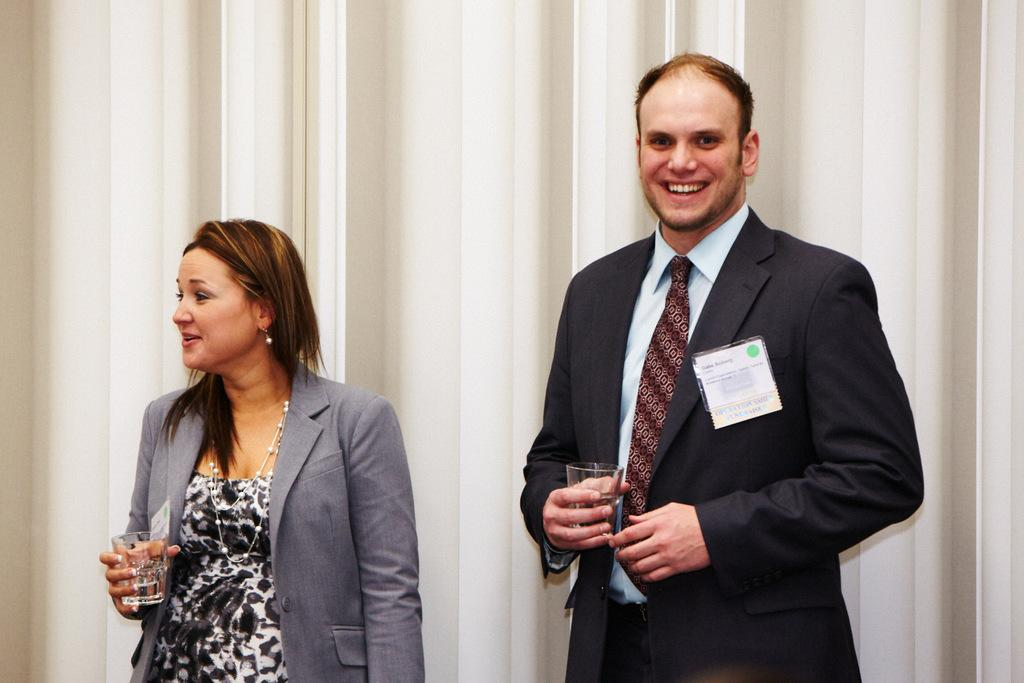Who is present in the image? There is a man and a lady in the image. What are the man and the lady doing in the image? Both the man and the lady are standing and smiling. What are they holding in their hands? The man and the lady are holding glasses in their hands. What can be seen in the background of the image? There is a curtain in the background of the image. What type of farm animals can be seen in the image? There are no farm animals present in the image. What kind of grape is the man holding in his hand? The man is not holding a grape in his hand; he is holding a glass. 